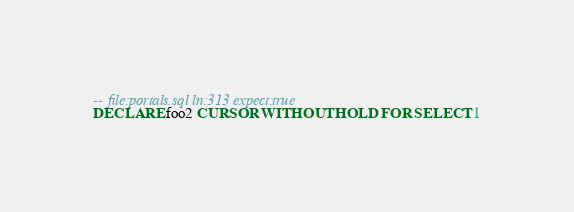<code> <loc_0><loc_0><loc_500><loc_500><_SQL_>-- file:portals.sql ln:313 expect:true
DECLARE foo2 CURSOR WITHOUT HOLD FOR SELECT 1
</code> 